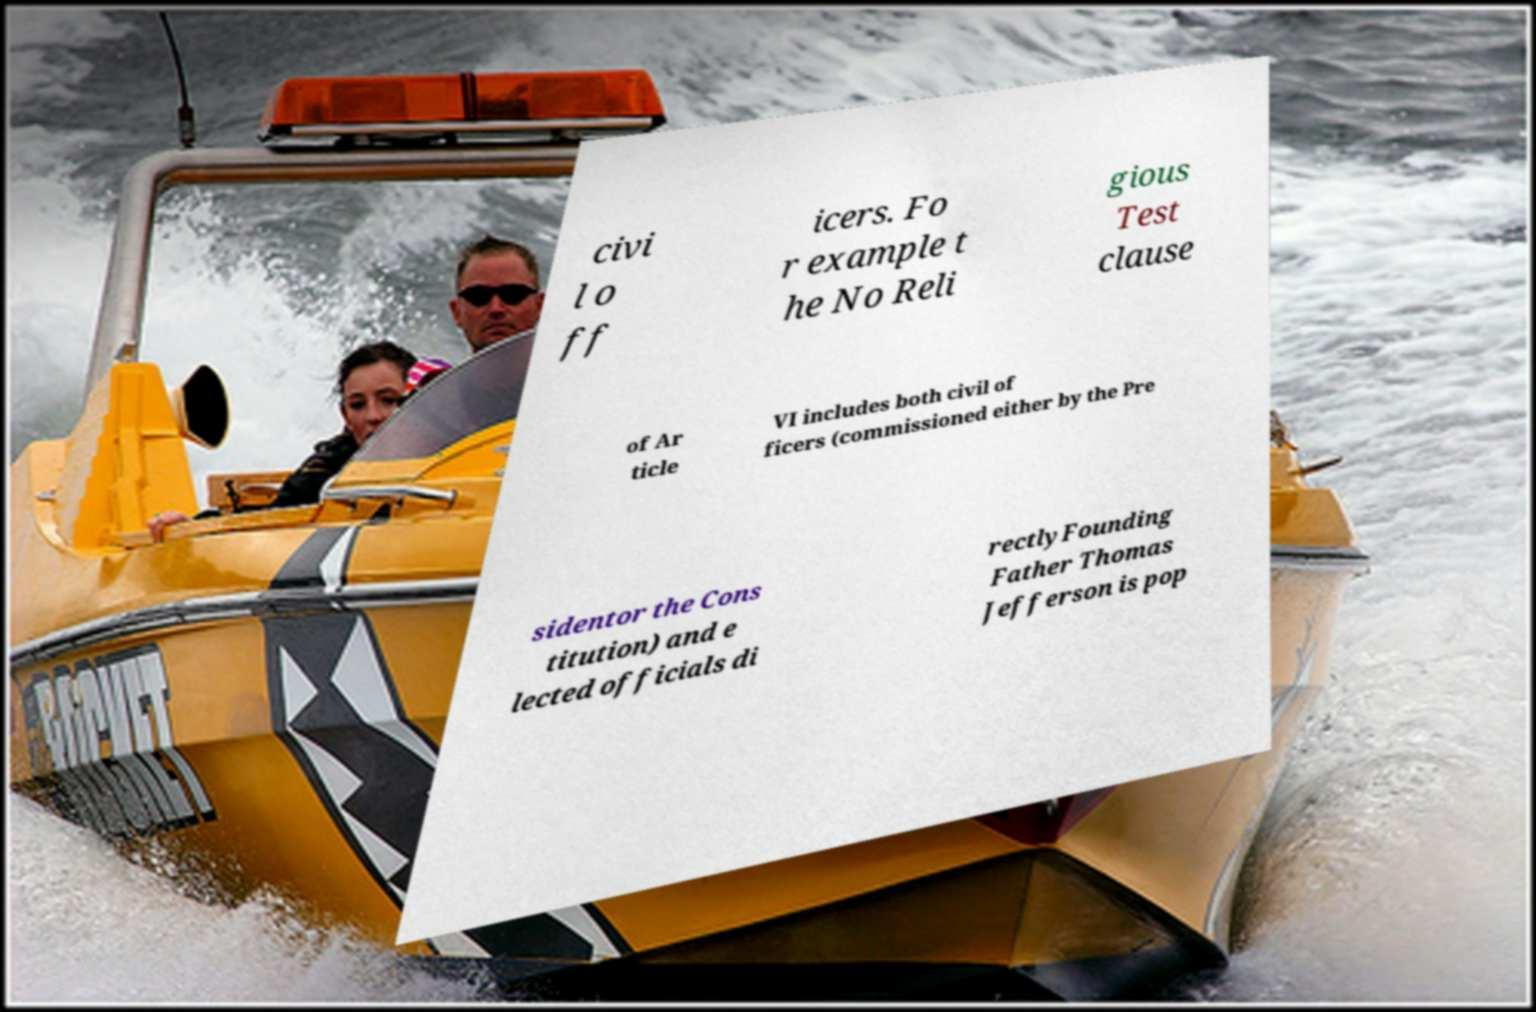Can you accurately transcribe the text from the provided image for me? civi l o ff icers. Fo r example t he No Reli gious Test clause of Ar ticle VI includes both civil of ficers (commissioned either by the Pre sidentor the Cons titution) and e lected officials di rectlyFounding Father Thomas Jefferson is pop 